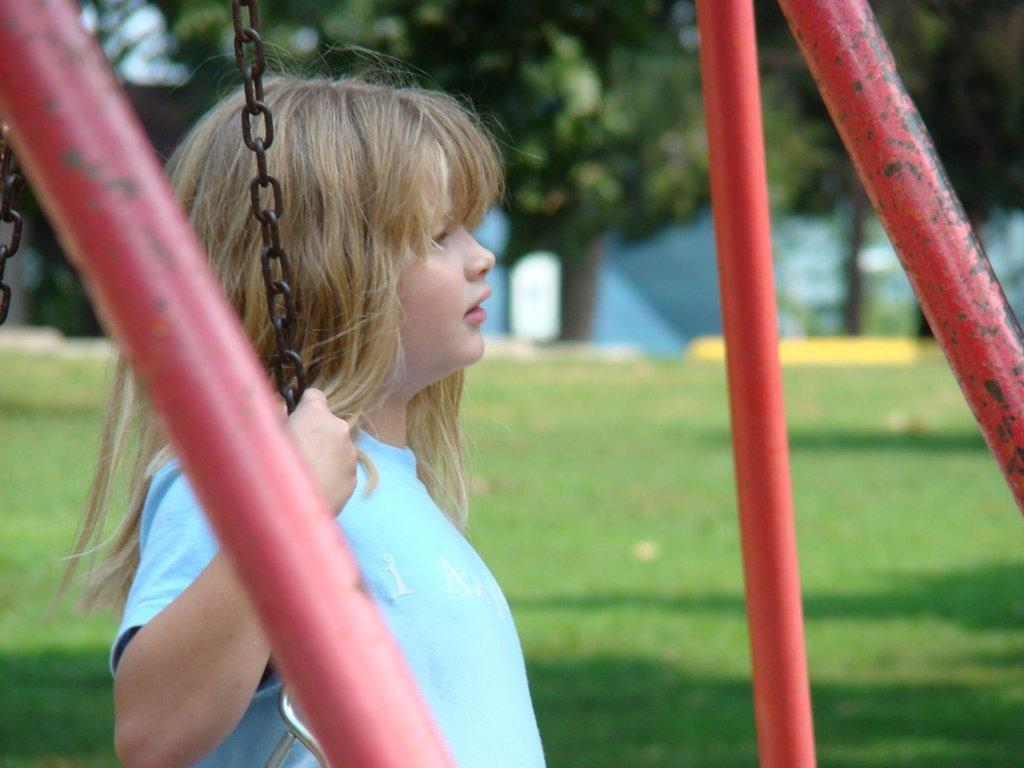What objects are in the foreground of the image? There are iron poles and a girl holding a chain in the foreground of the image. What type of vegetation is in the middle of the image? There is grass in the middle of the image. What can be seen in the background of the image? There are trees and a blue color object in the background of the image. How many tomatoes are on the girl's head in the image? There are no tomatoes present on the girl's head in the image. What type of vase is holding the flowers in the image? There is no vase or flowers present in the image. 